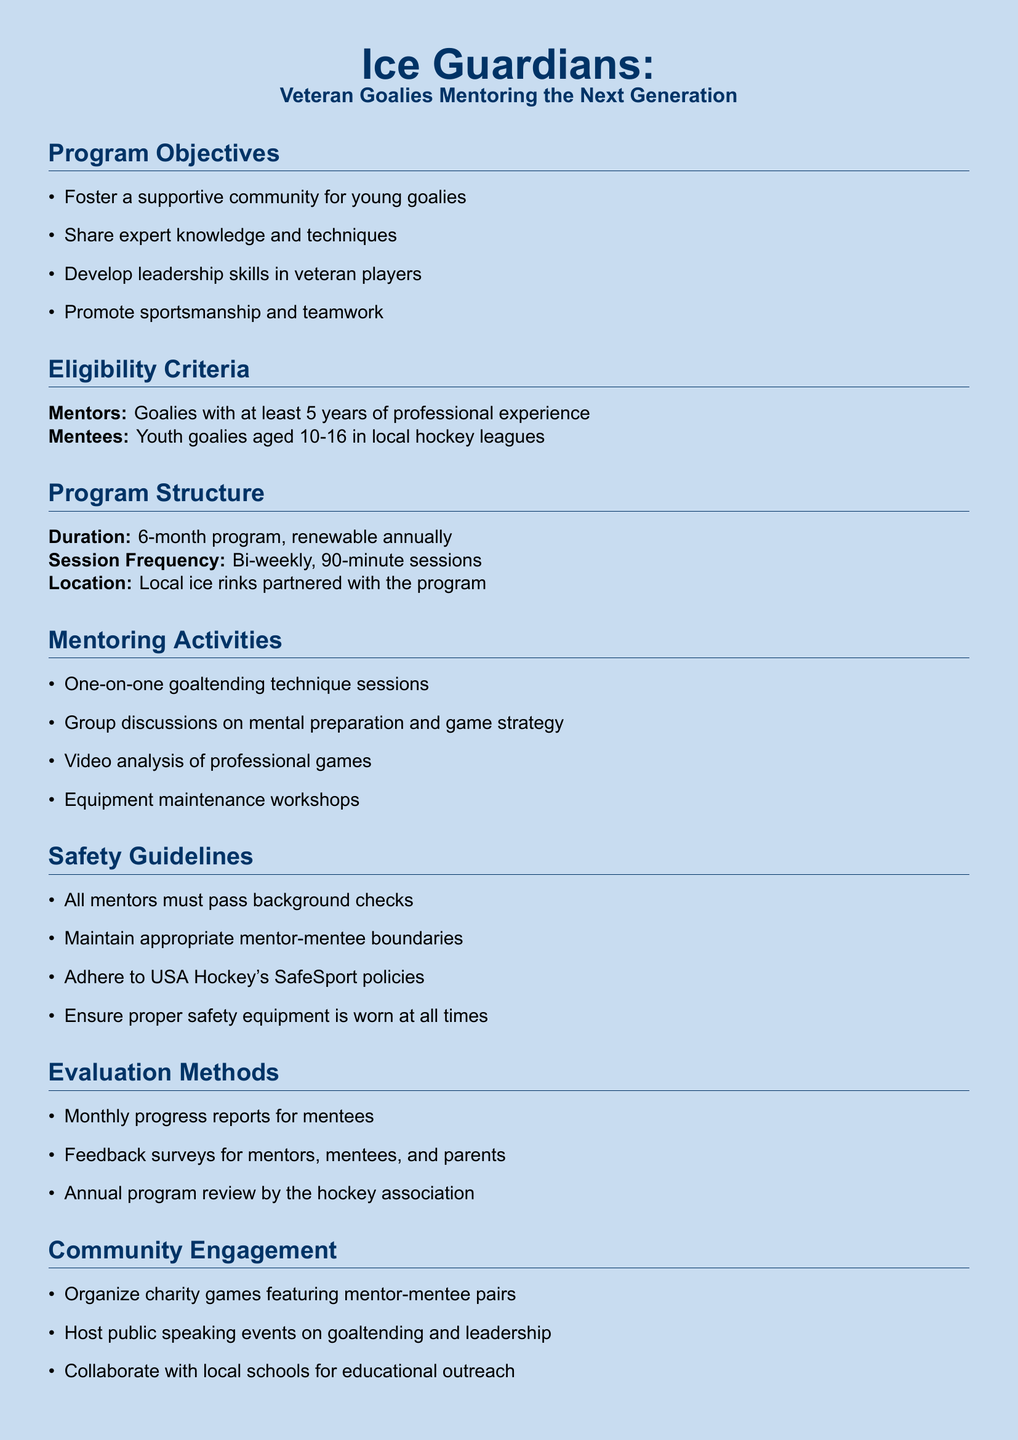What is the program duration? The program duration is specified in the document as a 6-month program, which can be renewed annually.
Answer: 6-month Who are the eligible mentees? The eligible mentees are described in the document as youth goalies within a specific age range.
Answer: Youth goalies aged 10-16 How often do sessions occur? The session frequency is stated in the document, indicating how often sessions will take place.
Answer: Bi-weekly What type of resource is provided to mentees? The document lists various resources for mentees, identifying one specific type provided.
Answer: Personal goaltending journal What must mentors pass to participate in the program? The document outlines safety guidelines, including a requirement for mentors in the program.
Answer: Background checks How many activities are listed under mentoring activities? Counting from the document under mentoring activities will reveal a specific figure.
Answer: Four activities What is the focus of monthly reports? The evaluation methods section indicates the subject focus of the monthly reports for mentees.
Answer: Progress What is one community engagement activity mentioned? The document provides examples of community engagement, identifying one specific activity.
Answer: Charity games What clothing item is provided to mentees? The resources section for mentees in the document mentions a specific clothing item issued as part of the program.
Answer: Program t-shirt 